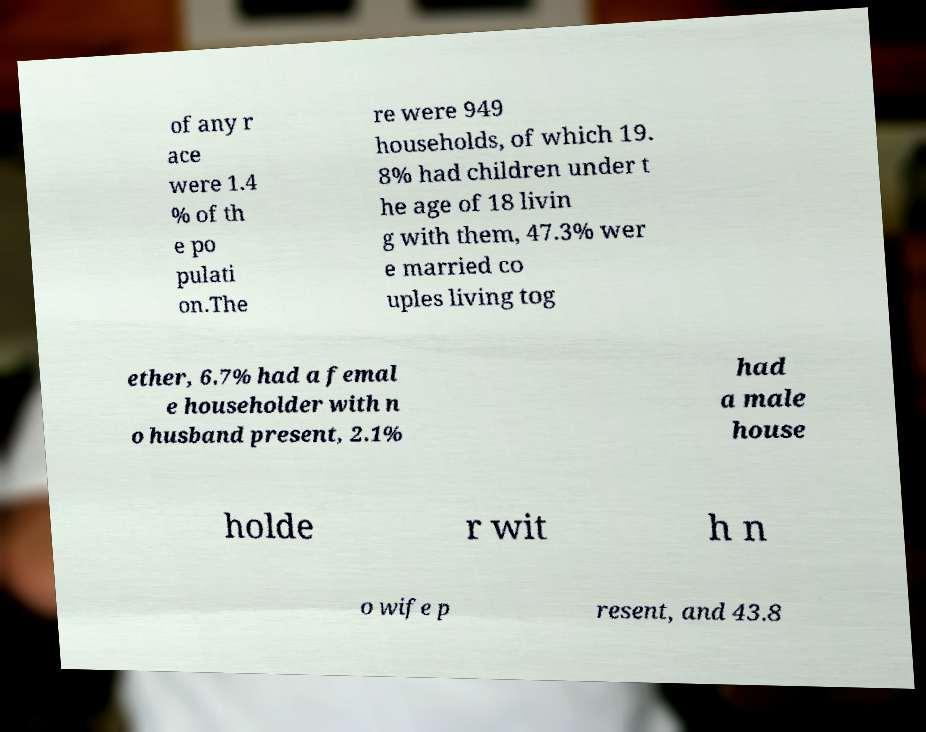Please identify and transcribe the text found in this image. of any r ace were 1.4 % of th e po pulati on.The re were 949 households, of which 19. 8% had children under t he age of 18 livin g with them, 47.3% wer e married co uples living tog ether, 6.7% had a femal e householder with n o husband present, 2.1% had a male house holde r wit h n o wife p resent, and 43.8 